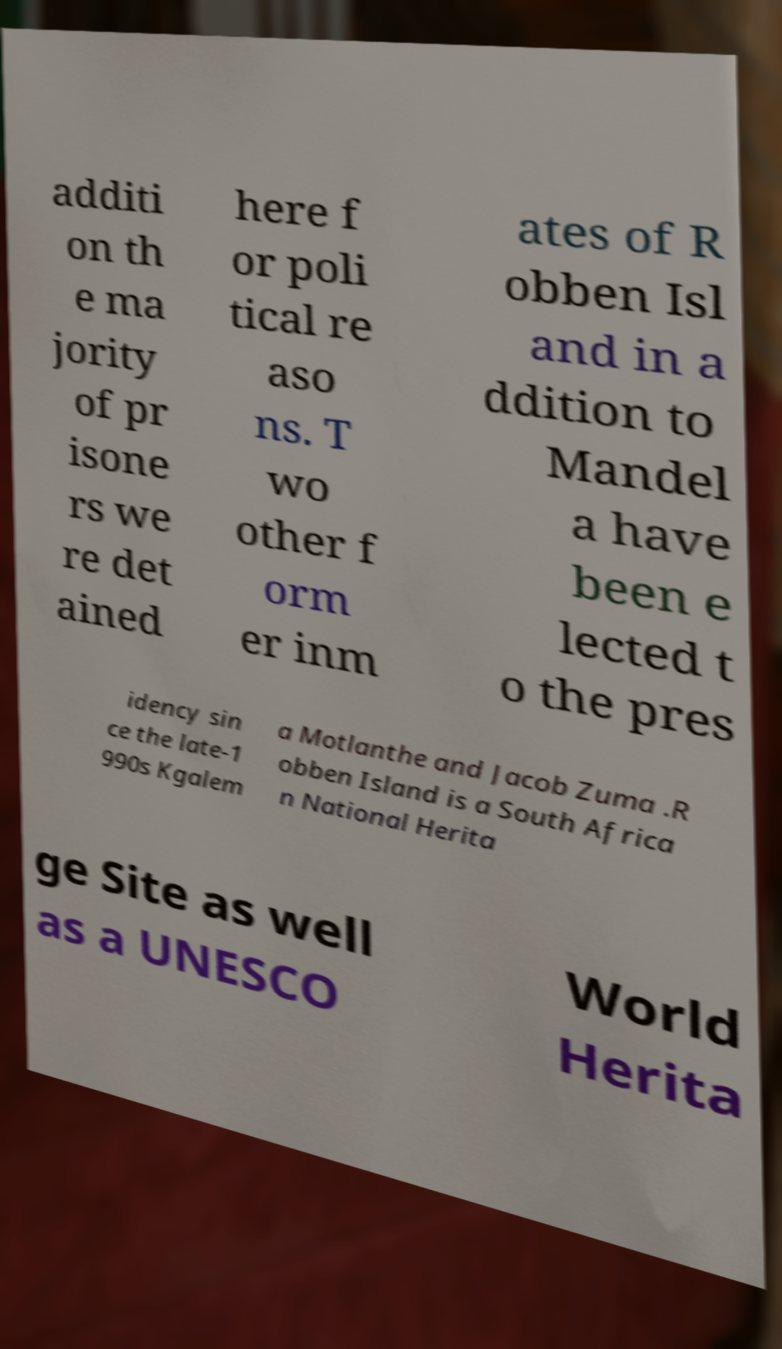Please identify and transcribe the text found in this image. additi on th e ma jority of pr isone rs we re det ained here f or poli tical re aso ns. T wo other f orm er inm ates of R obben Isl and in a ddition to Mandel a have been e lected t o the pres idency sin ce the late-1 990s Kgalem a Motlanthe and Jacob Zuma .R obben Island is a South Africa n National Herita ge Site as well as a UNESCO World Herita 